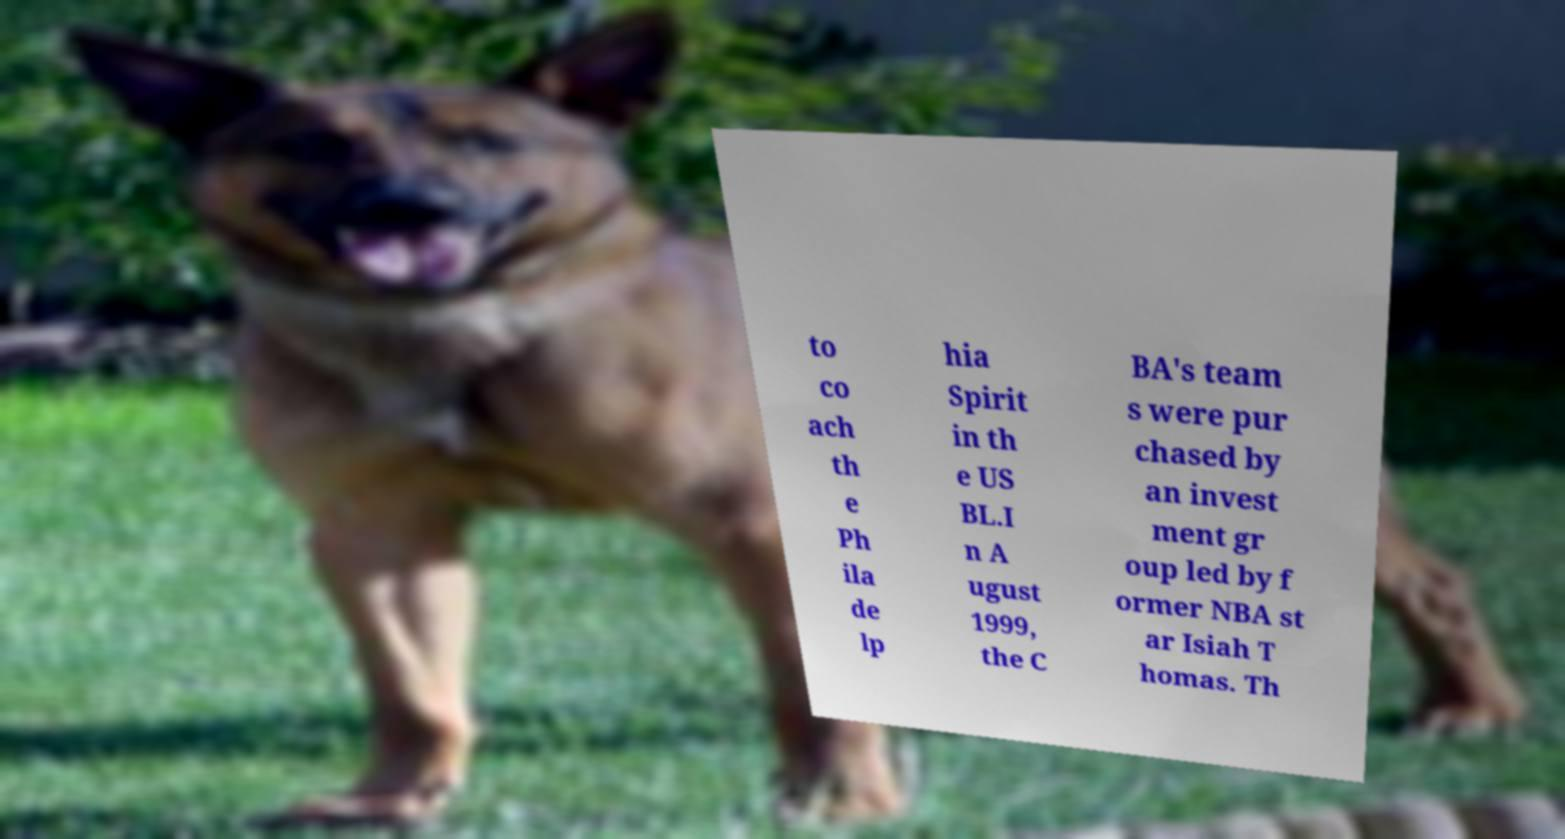Please read and relay the text visible in this image. What does it say? to co ach th e Ph ila de lp hia Spirit in th e US BL.I n A ugust 1999, the C BA's team s were pur chased by an invest ment gr oup led by f ormer NBA st ar Isiah T homas. Th 